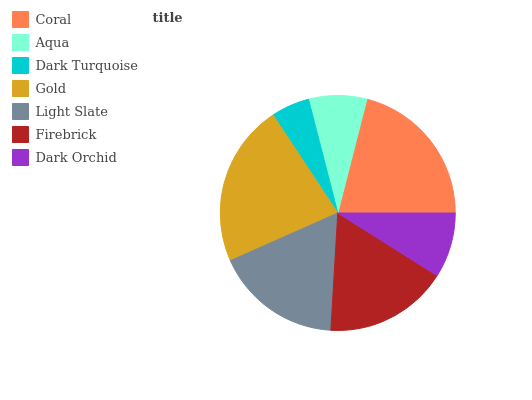Is Dark Turquoise the minimum?
Answer yes or no. Yes. Is Gold the maximum?
Answer yes or no. Yes. Is Aqua the minimum?
Answer yes or no. No. Is Aqua the maximum?
Answer yes or no. No. Is Coral greater than Aqua?
Answer yes or no. Yes. Is Aqua less than Coral?
Answer yes or no. Yes. Is Aqua greater than Coral?
Answer yes or no. No. Is Coral less than Aqua?
Answer yes or no. No. Is Firebrick the high median?
Answer yes or no. Yes. Is Firebrick the low median?
Answer yes or no. Yes. Is Light Slate the high median?
Answer yes or no. No. Is Gold the low median?
Answer yes or no. No. 